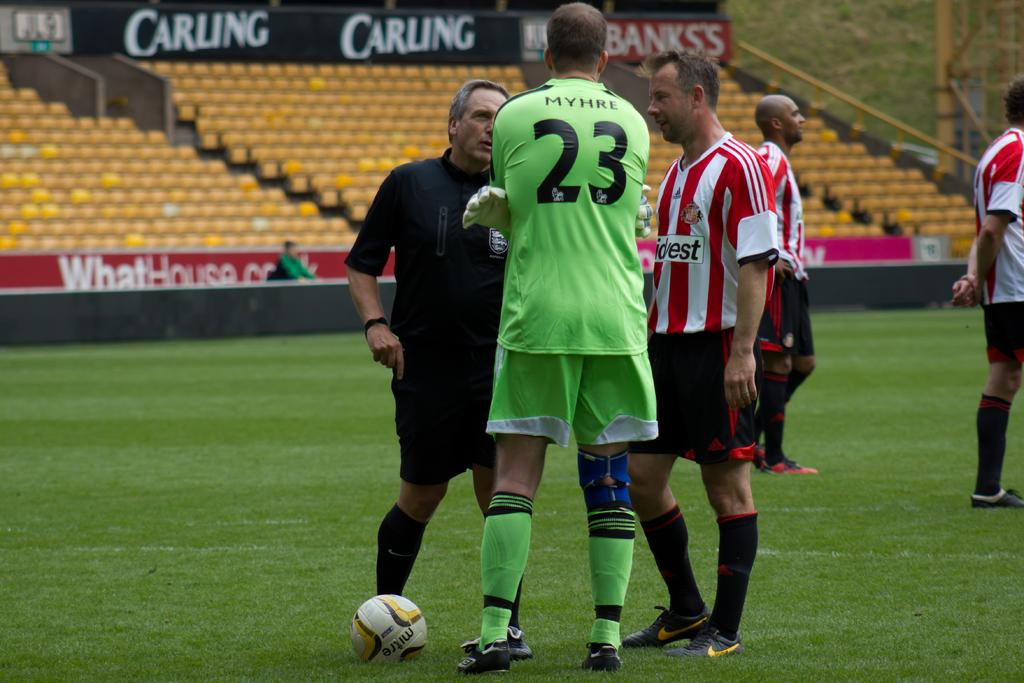<image>
Present a compact description of the photo's key features. A person wearing a jersey with the number 23 talks to two other men on a soccer field. 